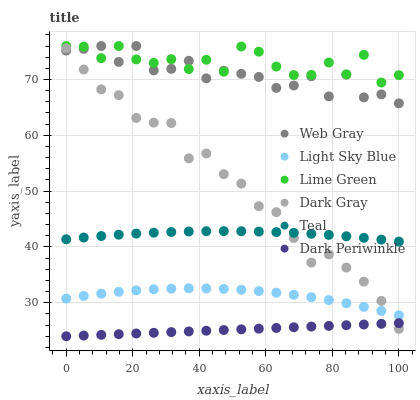Does Dark Periwinkle have the minimum area under the curve?
Answer yes or no. Yes. Does Lime Green have the maximum area under the curve?
Answer yes or no. Yes. Does Dark Gray have the minimum area under the curve?
Answer yes or no. No. Does Dark Gray have the maximum area under the curve?
Answer yes or no. No. Is Dark Periwinkle the smoothest?
Answer yes or no. Yes. Is Lime Green the roughest?
Answer yes or no. Yes. Is Dark Gray the smoothest?
Answer yes or no. No. Is Dark Gray the roughest?
Answer yes or no. No. Does Dark Periwinkle have the lowest value?
Answer yes or no. Yes. Does Dark Gray have the lowest value?
Answer yes or no. No. Does Lime Green have the highest value?
Answer yes or no. Yes. Does Dark Gray have the highest value?
Answer yes or no. No. Is Dark Periwinkle less than Light Sky Blue?
Answer yes or no. Yes. Is Web Gray greater than Dark Periwinkle?
Answer yes or no. Yes. Does Dark Gray intersect Light Sky Blue?
Answer yes or no. Yes. Is Dark Gray less than Light Sky Blue?
Answer yes or no. No. Is Dark Gray greater than Light Sky Blue?
Answer yes or no. No. Does Dark Periwinkle intersect Light Sky Blue?
Answer yes or no. No. 